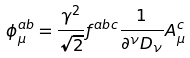Convert formula to latex. <formula><loc_0><loc_0><loc_500><loc_500>\phi ^ { a b } _ { \mu } = \frac { \gamma ^ { 2 } } { \sqrt { 2 } } f ^ { a b c } \frac { 1 } { \partial ^ { \nu } D _ { \nu } } A ^ { c } _ { \mu }</formula> 